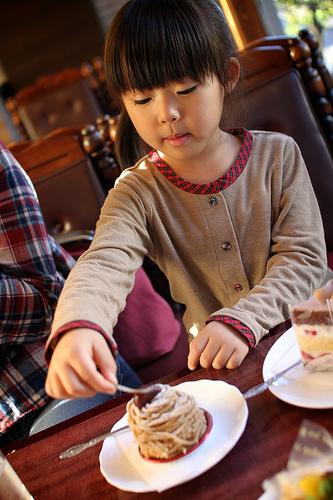Count the total number of people and the total number of eating utensils in the image. There are two people and three eating utensils in the image. What is the overall mood or sentiment of the image? The image has a pleasant and casual mood, featuring a child with a meal and a person nearby. Examine the image and describe the relationships between various objects in it. The girl is holding a spoon close to the plate with spaghetti, while a cake on a separate plate and a person with a plaid shirt are next to her. What can you assume about the location or settings, based on the objects and actions seen in the image? The image appears to be in a casual dining environment, probably a home, with a brown table and various dishes being served. In simple words, detail a central action taking place in the image. The little girl twirls spaghetti noodles on her plate with a fork. Mention any unusual elements or decorations you can observe in the image. There is scroll work on a chair back and red object behind the person in the image. Provide a description of the hairstyle and outfit of the main person in the image. The girl has straight dark hair with bangs, wears a plaid shirt with red checked cuffs, and has a small shirt button. How many plates with dessert appear in the image and what do they look like? There are 3 plates: a small white plate with dessert, a white plate with cake on it, and a white plate next to the noodle dish with cake. Describe any notable objects or details about the utensils within the picture. There are three pieces of silverware, including a silver fork that is partly visible and a steel eating implement on a plate. Based on the visual information, evaluate the quality of the image in terms of clarity and composition. The image is of decent quality with clear identification of people, objects, and their interactions, as well as a balanced composition of elements. Is the girl eating with a spoon, fork or a knife? Spoon Analyze the girl's haircut. The girl has bangs above her eyes What is behind the person with the plaid shirt? Red object What type of cake is on the white plate? Cake with the noodle shapes What is the color of the tree leaves in the image? Green What color and pattern is the tablecloth? Brown table without a tablecloth Look at the bright yellow sun shining through the window onto the girl's hair. No, it's not mentioned in the image. Can you find the large blue dog hiding under the table? There is no mention of a dog, large or small, or anything blue in the list of objects. The presence of a large blue dog under the table would be an unexpected element and may lead viewers to search for it. How many pieces of silverware can you see in the image? Three What is the person next to the girl wearing? Red and blue checked shirt What is on the white plate next to the noodle dish? Cake What pattern is on the girl's shirt? Red and black checks What kind of hair does the girl have? Straight, dark brown hair Describe the shirt button in the image. A small shirt button Identify the activity the girl is doing with the spaghetti. Twirling the spaghetti What type of eating implement is on the plate? Steel eating implement What is the shape of the white plate? Round What is the color of the girl's shirt cuffs? Red checked Which person is wearing a red and blue checked shirt? Person next to the girl What emotion is the girl displaying in the image? Neutral What color is the table? Brown Observe the boy peeking behind the girl with the plaid shirt. There is no mention of a boy, just a girl with dark hair, a child's head with bangs, and a person with a plaid shirt. This instruction may confuse viewers, as they try to find an additional character that does not exist in the image. 